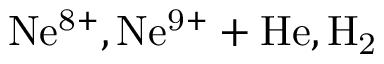<formula> <loc_0><loc_0><loc_500><loc_500>N e ^ { 8 + } , N e ^ { 9 + } + H e , H _ { 2 }</formula> 